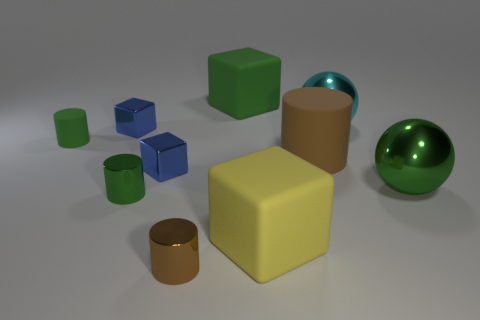There is a big object that is behind the sphere behind the big brown rubber cylinder; what shape is it?
Provide a short and direct response. Cube. Are there fewer big green spheres in front of the brown metal thing than small green objects?
Keep it short and to the point. Yes. The big brown matte thing has what shape?
Ensure brevity in your answer.  Cylinder. There is a brown object that is in front of the green metal ball; how big is it?
Provide a short and direct response. Small. There is another sphere that is the same size as the cyan sphere; what color is it?
Provide a short and direct response. Green. Are there any matte objects that have the same color as the large rubber cylinder?
Keep it short and to the point. No. Are there fewer cyan objects in front of the big yellow rubber block than large cyan objects right of the cyan metallic thing?
Offer a very short reply. No. What is the material of the big object that is both in front of the large cyan sphere and to the left of the brown matte thing?
Ensure brevity in your answer.  Rubber. Does the big green rubber object have the same shape as the big metal thing that is to the left of the green ball?
Your answer should be very brief. No. How many other things are there of the same size as the yellow thing?
Offer a terse response. 4. 